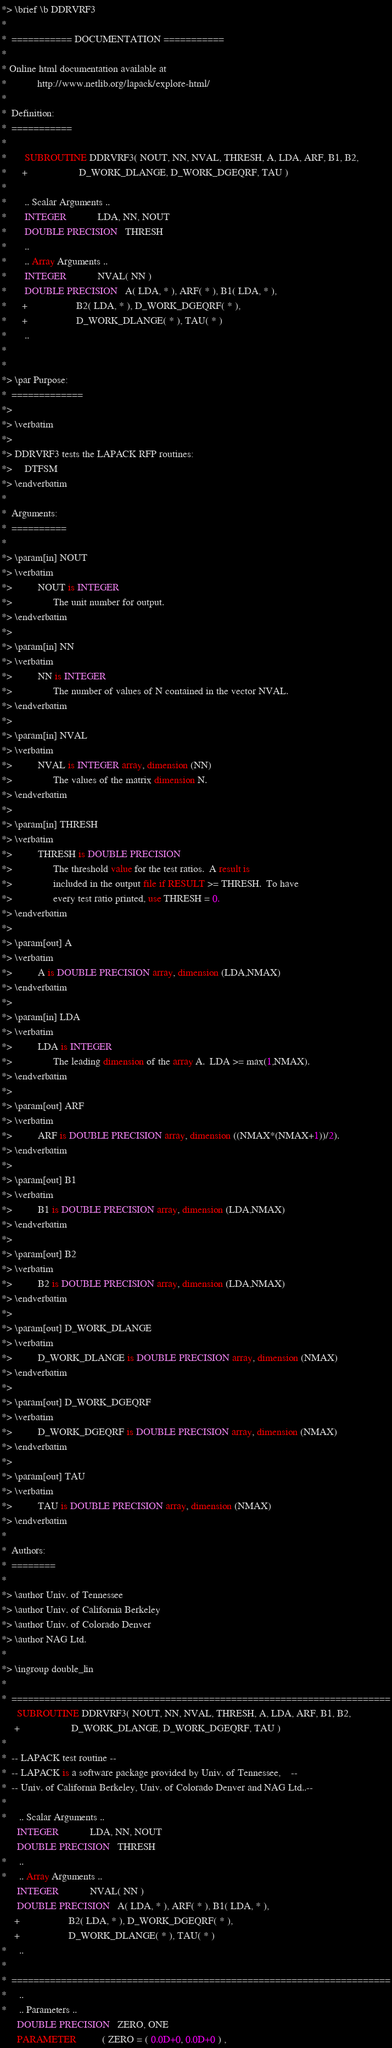<code> <loc_0><loc_0><loc_500><loc_500><_FORTRAN_>*> \brief \b DDRVRF3
*
*  =========== DOCUMENTATION ===========
*
* Online html documentation available at
*            http://www.netlib.org/lapack/explore-html/
*
*  Definition:
*  ===========
*
*       SUBROUTINE DDRVRF3( NOUT, NN, NVAL, THRESH, A, LDA, ARF, B1, B2,
*      +                    D_WORK_DLANGE, D_WORK_DGEQRF, TAU )
*
*       .. Scalar Arguments ..
*       INTEGER            LDA, NN, NOUT
*       DOUBLE PRECISION   THRESH
*       ..
*       .. Array Arguments ..
*       INTEGER            NVAL( NN )
*       DOUBLE PRECISION   A( LDA, * ), ARF( * ), B1( LDA, * ),
*      +                   B2( LDA, * ), D_WORK_DGEQRF( * ),
*      +                   D_WORK_DLANGE( * ), TAU( * )
*       ..
*
*
*> \par Purpose:
*  =============
*>
*> \verbatim
*>
*> DDRVRF3 tests the LAPACK RFP routines:
*>     DTFSM
*> \endverbatim
*
*  Arguments:
*  ==========
*
*> \param[in] NOUT
*> \verbatim
*>          NOUT is INTEGER
*>                The unit number for output.
*> \endverbatim
*>
*> \param[in] NN
*> \verbatim
*>          NN is INTEGER
*>                The number of values of N contained in the vector NVAL.
*> \endverbatim
*>
*> \param[in] NVAL
*> \verbatim
*>          NVAL is INTEGER array, dimension (NN)
*>                The values of the matrix dimension N.
*> \endverbatim
*>
*> \param[in] THRESH
*> \verbatim
*>          THRESH is DOUBLE PRECISION
*>                The threshold value for the test ratios.  A result is
*>                included in the output file if RESULT >= THRESH.  To have
*>                every test ratio printed, use THRESH = 0.
*> \endverbatim
*>
*> \param[out] A
*> \verbatim
*>          A is DOUBLE PRECISION array, dimension (LDA,NMAX)
*> \endverbatim
*>
*> \param[in] LDA
*> \verbatim
*>          LDA is INTEGER
*>                The leading dimension of the array A.  LDA >= max(1,NMAX).
*> \endverbatim
*>
*> \param[out] ARF
*> \verbatim
*>          ARF is DOUBLE PRECISION array, dimension ((NMAX*(NMAX+1))/2).
*> \endverbatim
*>
*> \param[out] B1
*> \verbatim
*>          B1 is DOUBLE PRECISION array, dimension (LDA,NMAX)
*> \endverbatim
*>
*> \param[out] B2
*> \verbatim
*>          B2 is DOUBLE PRECISION array, dimension (LDA,NMAX)
*> \endverbatim
*>
*> \param[out] D_WORK_DLANGE
*> \verbatim
*>          D_WORK_DLANGE is DOUBLE PRECISION array, dimension (NMAX)
*> \endverbatim
*>
*> \param[out] D_WORK_DGEQRF
*> \verbatim
*>          D_WORK_DGEQRF is DOUBLE PRECISION array, dimension (NMAX)
*> \endverbatim
*>
*> \param[out] TAU
*> \verbatim
*>          TAU is DOUBLE PRECISION array, dimension (NMAX)
*> \endverbatim
*
*  Authors:
*  ========
*
*> \author Univ. of Tennessee
*> \author Univ. of California Berkeley
*> \author Univ. of Colorado Denver
*> \author NAG Ltd.
*
*> \ingroup double_lin
*
*  =====================================================================
      SUBROUTINE DDRVRF3( NOUT, NN, NVAL, THRESH, A, LDA, ARF, B1, B2,
     +                    D_WORK_DLANGE, D_WORK_DGEQRF, TAU )
*
*  -- LAPACK test routine --
*  -- LAPACK is a software package provided by Univ. of Tennessee,    --
*  -- Univ. of California Berkeley, Univ. of Colorado Denver and NAG Ltd..--
*
*     .. Scalar Arguments ..
      INTEGER            LDA, NN, NOUT
      DOUBLE PRECISION   THRESH
*     ..
*     .. Array Arguments ..
      INTEGER            NVAL( NN )
      DOUBLE PRECISION   A( LDA, * ), ARF( * ), B1( LDA, * ),
     +                   B2( LDA, * ), D_WORK_DGEQRF( * ),
     +                   D_WORK_DLANGE( * ), TAU( * )
*     ..
*
*  =====================================================================
*     ..
*     .. Parameters ..
      DOUBLE PRECISION   ZERO, ONE
      PARAMETER          ( ZERO = ( 0.0D+0, 0.0D+0 ) ,</code> 